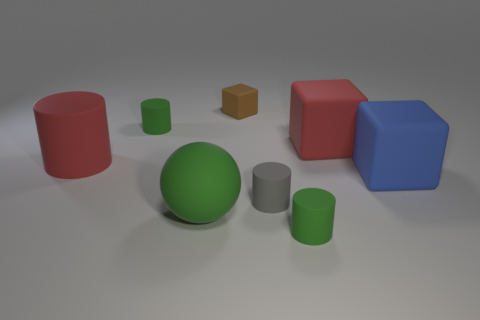Add 1 tiny things. How many objects exist? 9 Subtract all small cylinders. How many cylinders are left? 1 Subtract 1 blocks. How many blocks are left? 2 Subtract all brown cylinders. Subtract all purple balls. How many cylinders are left? 4 Subtract all cyan cubes. How many red cylinders are left? 1 Subtract all large things. Subtract all green matte spheres. How many objects are left? 3 Add 7 brown rubber objects. How many brown rubber objects are left? 8 Add 5 green cylinders. How many green cylinders exist? 7 Subtract all red blocks. How many blocks are left? 2 Subtract 0 cyan blocks. How many objects are left? 8 